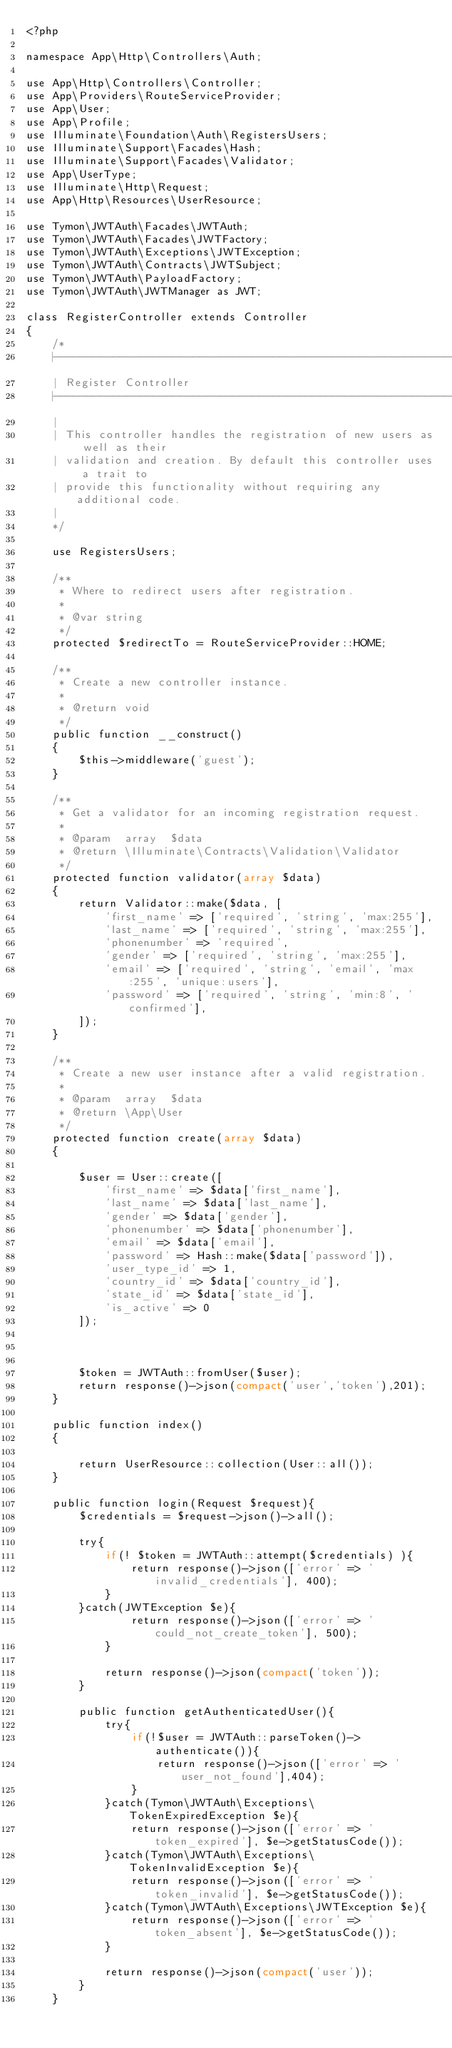<code> <loc_0><loc_0><loc_500><loc_500><_PHP_><?php

namespace App\Http\Controllers\Auth;

use App\Http\Controllers\Controller;
use App\Providers\RouteServiceProvider;
use App\User;
use App\Profile;
use Illuminate\Foundation\Auth\RegistersUsers;
use Illuminate\Support\Facades\Hash;
use Illuminate\Support\Facades\Validator;
use App\UserType;
use Illuminate\Http\Request;
use App\Http\Resources\UserResource;

use Tymon\JWTAuth\Facades\JWTAuth;
use Tymon\JWTAuth\Facades\JWTFactory;
use Tymon\JWTAuth\Exceptions\JWTException;
use Tymon\JWTAuth\Contracts\JWTSubject;
use Tymon\JWTAuth\PayloadFactory;
use Tymon\JWTAuth\JWTManager as JWT;

class RegisterController extends Controller
{
    /*
    |--------------------------------------------------------------------------
    | Register Controller
    |--------------------------------------------------------------------------
    |
    | This controller handles the registration of new users as well as their
    | validation and creation. By default this controller uses a trait to
    | provide this functionality without requiring any additional code.
    |
    */

    use RegistersUsers;

    /**
     * Where to redirect users after registration.
     *
     * @var string
     */
    protected $redirectTo = RouteServiceProvider::HOME;

    /**
     * Create a new controller instance.
     *
     * @return void
     */
    public function __construct()
    {
        $this->middleware('guest');
    }

    /**
     * Get a validator for an incoming registration request.
     *
     * @param  array  $data
     * @return \Illuminate\Contracts\Validation\Validator
     */
    protected function validator(array $data)
    {
        return Validator::make($data, [
            'first_name' => ['required', 'string', 'max:255'],
            'last_name' => ['required', 'string', 'max:255'],
            'phonenumber' => 'required',
            'gender' => ['required', 'string', 'max:255'],
            'email' => ['required', 'string', 'email', 'max:255', 'unique:users'],
            'password' => ['required', 'string', 'min:8', 'confirmed'],
        ]);
    }

    /**
     * Create a new user instance after a valid registration.
     *
     * @param  array  $data
     * @return \App\User
     */
    protected function create(array $data)
    {

        $user = User::create([
            'first_name' => $data['first_name'],
            'last_name' => $data['last_name'],
            'gender' => $data['gender'],
            'phonenumber' => $data['phonenumber'],
            'email' => $data['email'],
            'password' => Hash::make($data['password']),
            'user_type_id' => 1,
            'country_id' => $data['country_id'],
            'state_id' => $data['state_id'],
            'is_active' => 0
        ]);

        

        $token = JWTAuth::fromUser($user);
        return response()->json(compact('user','token'),201);
    }

    public function index()
    {

        return UserResource::collection(User::all());
    }

    public function login(Request $request){
        $credentials = $request->json()->all();

        try{
            if(! $token = JWTAuth::attempt($credentials) ){
                return response()->json(['error' => 'invalid_credentials'], 400);
            }
        }catch(JWTException $e){
                return response()->json(['error' => 'could_not_create_token'], 500);
            }

            return response()->json(compact('token'));
        }

        public function getAuthenticatedUser(){
            try{
                if(!$user = JWTAuth::parseToken()->authenticate()){
                    return response()->json(['error' => 'user_not_found'],404);
                }
            }catch(Tymon\JWTAuth\Exceptions\TokenExpiredException $e){
                return response()->json(['error' => 'token_expired'], $e->getStatusCode());
            }catch(Tymon\JWTAuth\Exceptions\TokenInvalidException $e){
                return response()->json(['error' => 'token_invalid'], $e->getStatusCode());
            }catch(Tymon\JWTAuth\Exceptions\JWTException $e){
                return response()->json(['error' => 'token_absent'], $e->getStatusCode());
            }

            return response()->json(compact('user'));
        }
    }</code> 